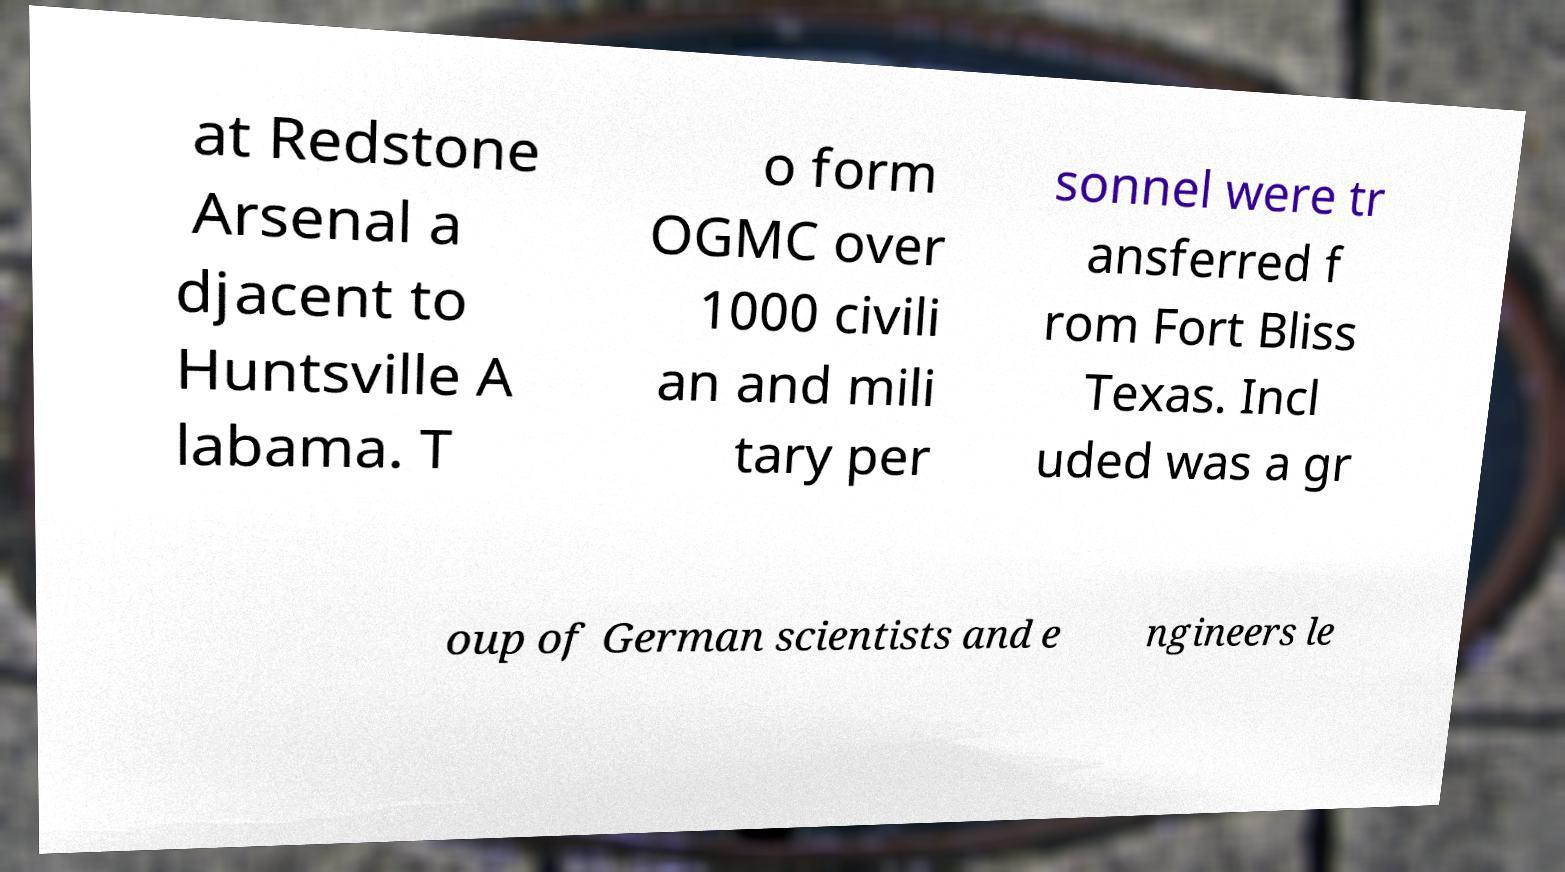Can you read and provide the text displayed in the image?This photo seems to have some interesting text. Can you extract and type it out for me? at Redstone Arsenal a djacent to Huntsville A labama. T o form OGMC over 1000 civili an and mili tary per sonnel were tr ansferred f rom Fort Bliss Texas. Incl uded was a gr oup of German scientists and e ngineers le 